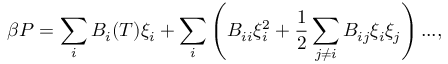Convert formula to latex. <formula><loc_0><loc_0><loc_500><loc_500>\beta P = \sum _ { i } B _ { i } ( T ) \xi _ { i } + \sum _ { i } \left ( B _ { i i } \xi _ { i } ^ { 2 } + \frac { 1 } { 2 } \sum _ { j \neq i } B _ { i j } \xi _ { i } \xi _ { j } \right ) \dots ,</formula> 